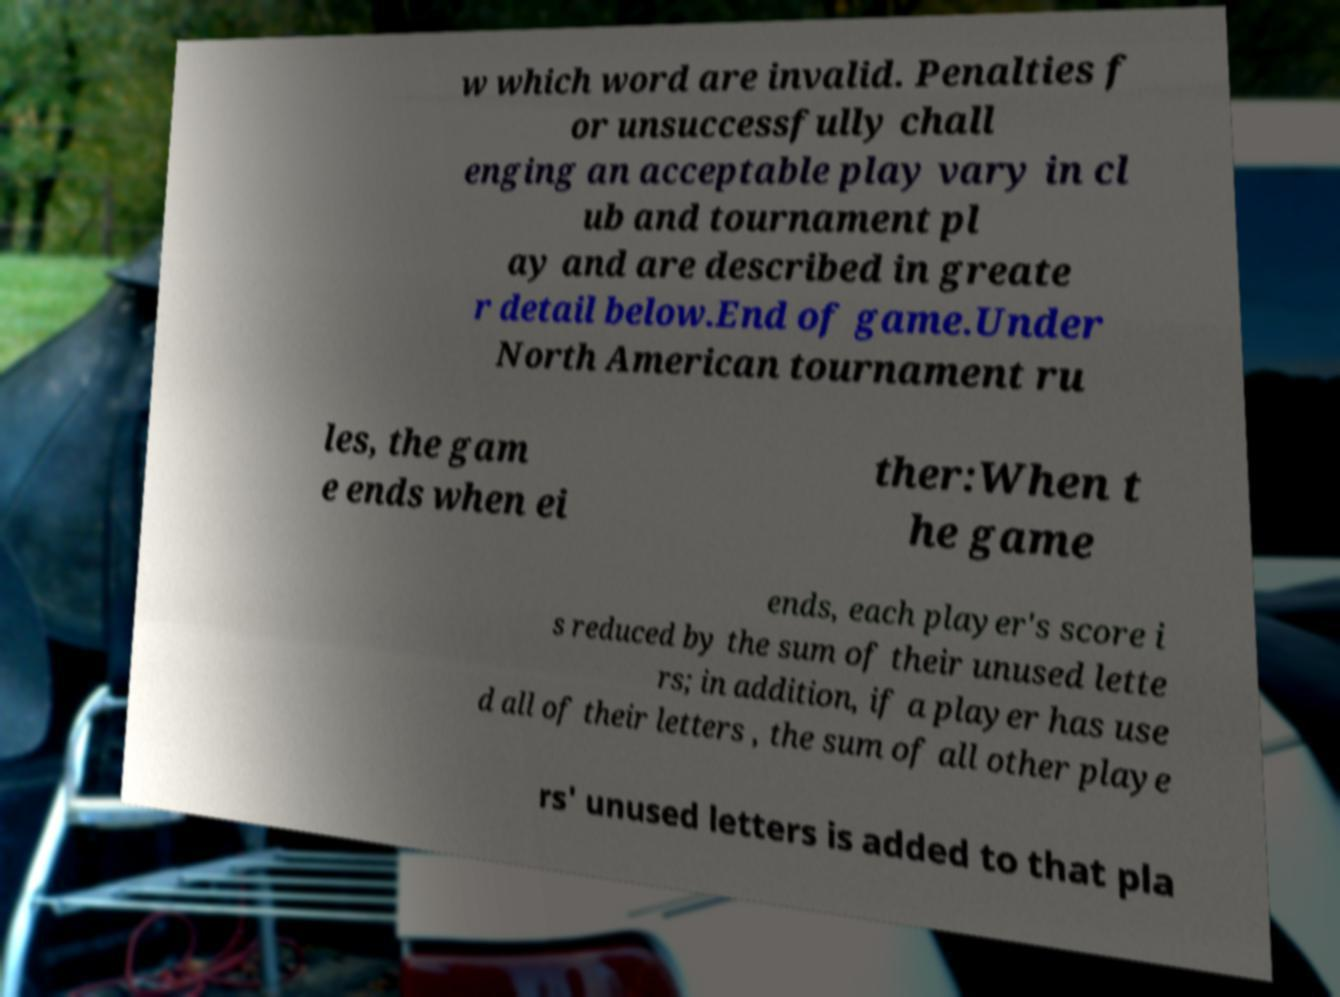Please identify and transcribe the text found in this image. w which word are invalid. Penalties f or unsuccessfully chall enging an acceptable play vary in cl ub and tournament pl ay and are described in greate r detail below.End of game.Under North American tournament ru les, the gam e ends when ei ther:When t he game ends, each player's score i s reduced by the sum of their unused lette rs; in addition, if a player has use d all of their letters , the sum of all other playe rs' unused letters is added to that pla 